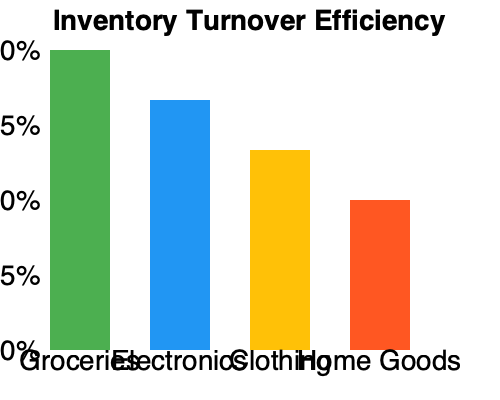As a chain store manager looking to expand in the Worcester area, you're analyzing inventory turnover efficiency across different product categories. Based on the bar chart showing inventory turnover percentages, which product category should be prioritized for expansion due to its high efficiency? To determine which product category should be prioritized for expansion due to high efficiency, we need to analyze the inventory turnover percentages shown in the bar chart. The higher the percentage, the more efficient the inventory turnover for that category. Let's examine each category:

1. Groceries: The bar reaches 100%, indicating the highest inventory turnover efficiency.
2. Electronics: The bar reaches approximately 75%, showing good efficiency but lower than groceries.
3. Clothing: The bar reaches about 50%, indicating moderate efficiency.
4. Home Goods: The bar reaches approximately 25%, showing the lowest efficiency among the categories.

Since we're looking to expand the brand's presence in the Worcester area, prioritizing the most efficient category would be strategic. This allows for quicker stock turnover, reduced holding costs, and potentially higher profits.

Given this analysis, the product category with the highest efficiency is Groceries, reaching 100% turnover. This suggests that grocery items are selling quickly and consistently, making it the ideal category to prioritize for expansion in the new market.
Answer: Groceries 